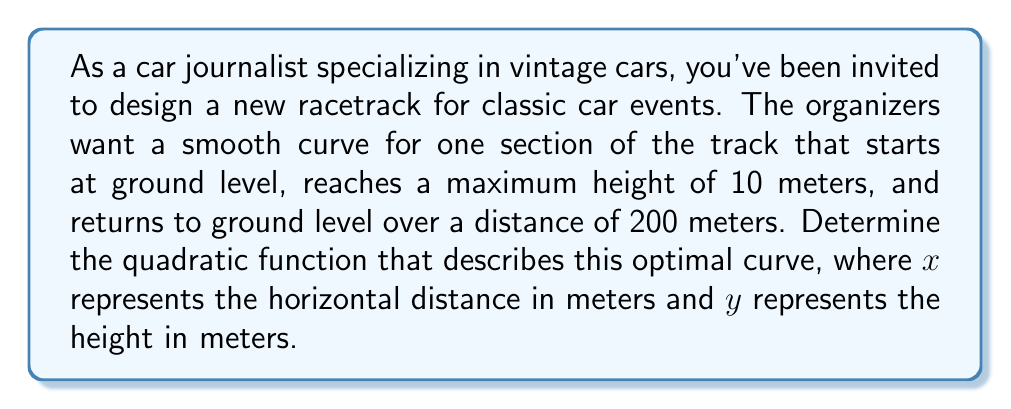Can you answer this question? To solve this problem, we need to use the general form of a quadratic function:

$$y = a(x-h)^2 + k$$

Where $(h,k)$ is the vertex of the parabola.

Given information:
- The curve starts and ends at ground level (y = 0)
- The maximum height is 10 meters
- The total horizontal distance is 200 meters

Step 1: Determine the vertex
The vertex will be at the highest point of the curve, which is (100, 10) since the maximum height is at the midpoint of the horizontal distance.

Step 2: Substitute the vertex into the general form
$$y = a(x-100)^2 + 10$$

Step 3: Use the fact that y = 0 when x = 0 or x = 200 to find 'a'
Let's use x = 0:
$$0 = a(0-100)^2 + 10$$
$$0 = 10000a + 10$$
$$-10 = 10000a$$
$$a = -\frac{1}{1000}$$

Step 4: Write the final equation
$$y = -\frac{1}{1000}(x-100)^2 + 10$$

This quadratic function describes the optimal curve for the racetrack section, providing a smooth transition that reaches the desired maximum height and returns to ground level over the specified distance.
Answer: $$y = -\frac{1}{1000}(x-100)^2 + 10$$ 